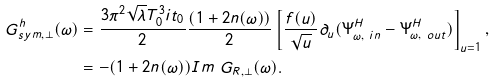Convert formula to latex. <formula><loc_0><loc_0><loc_500><loc_500>G ^ { h } _ { s y m , \perp } ( \omega ) & = \frac { 3 \pi ^ { 2 } \sqrt { \lambda } T _ { 0 } ^ { 3 } i t _ { 0 } } { 2 } \frac { ( 1 + 2 n ( \omega ) ) } { 2 } \left [ \frac { f ( u ) } { \sqrt { u } } \partial _ { u } ( \Psi ^ { H } _ { \omega , \ i n } - \Psi ^ { H } _ { \omega , \ o u t } ) \right ] _ { u = 1 } , \\ & = - ( 1 + 2 n ( \omega ) ) I m \ G _ { R , \perp } ( \omega ) .</formula> 